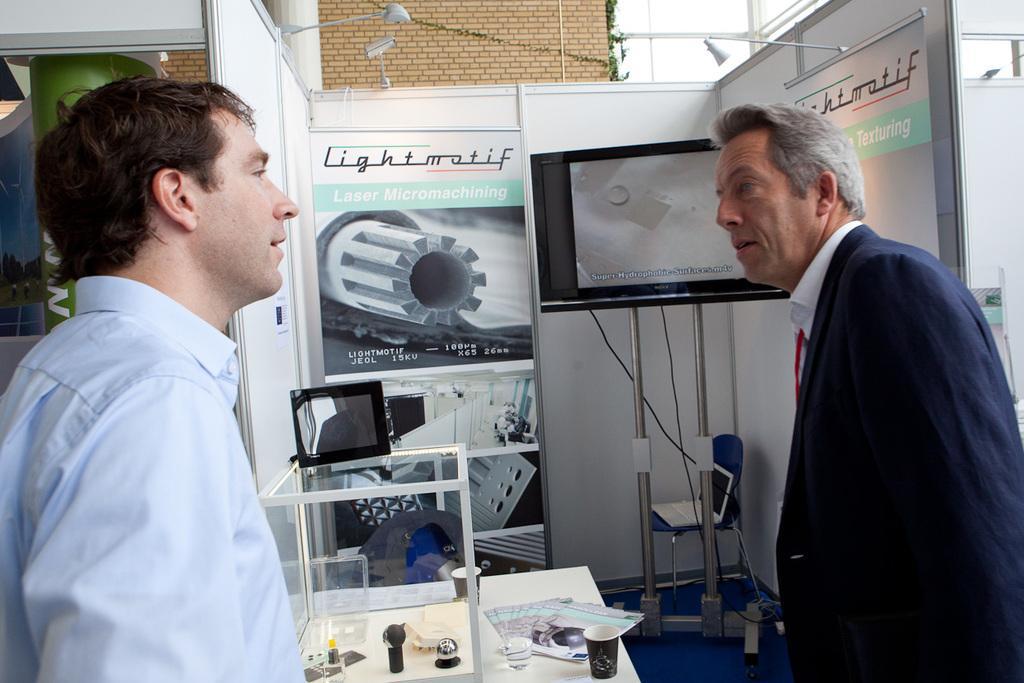Describe this image in one or two sentences. In the image we can see two men and they are wearing clothes. This is a screen, poster, light, brick wall, floor, paper, cup, glass box, cable wire, stand and leaves. 